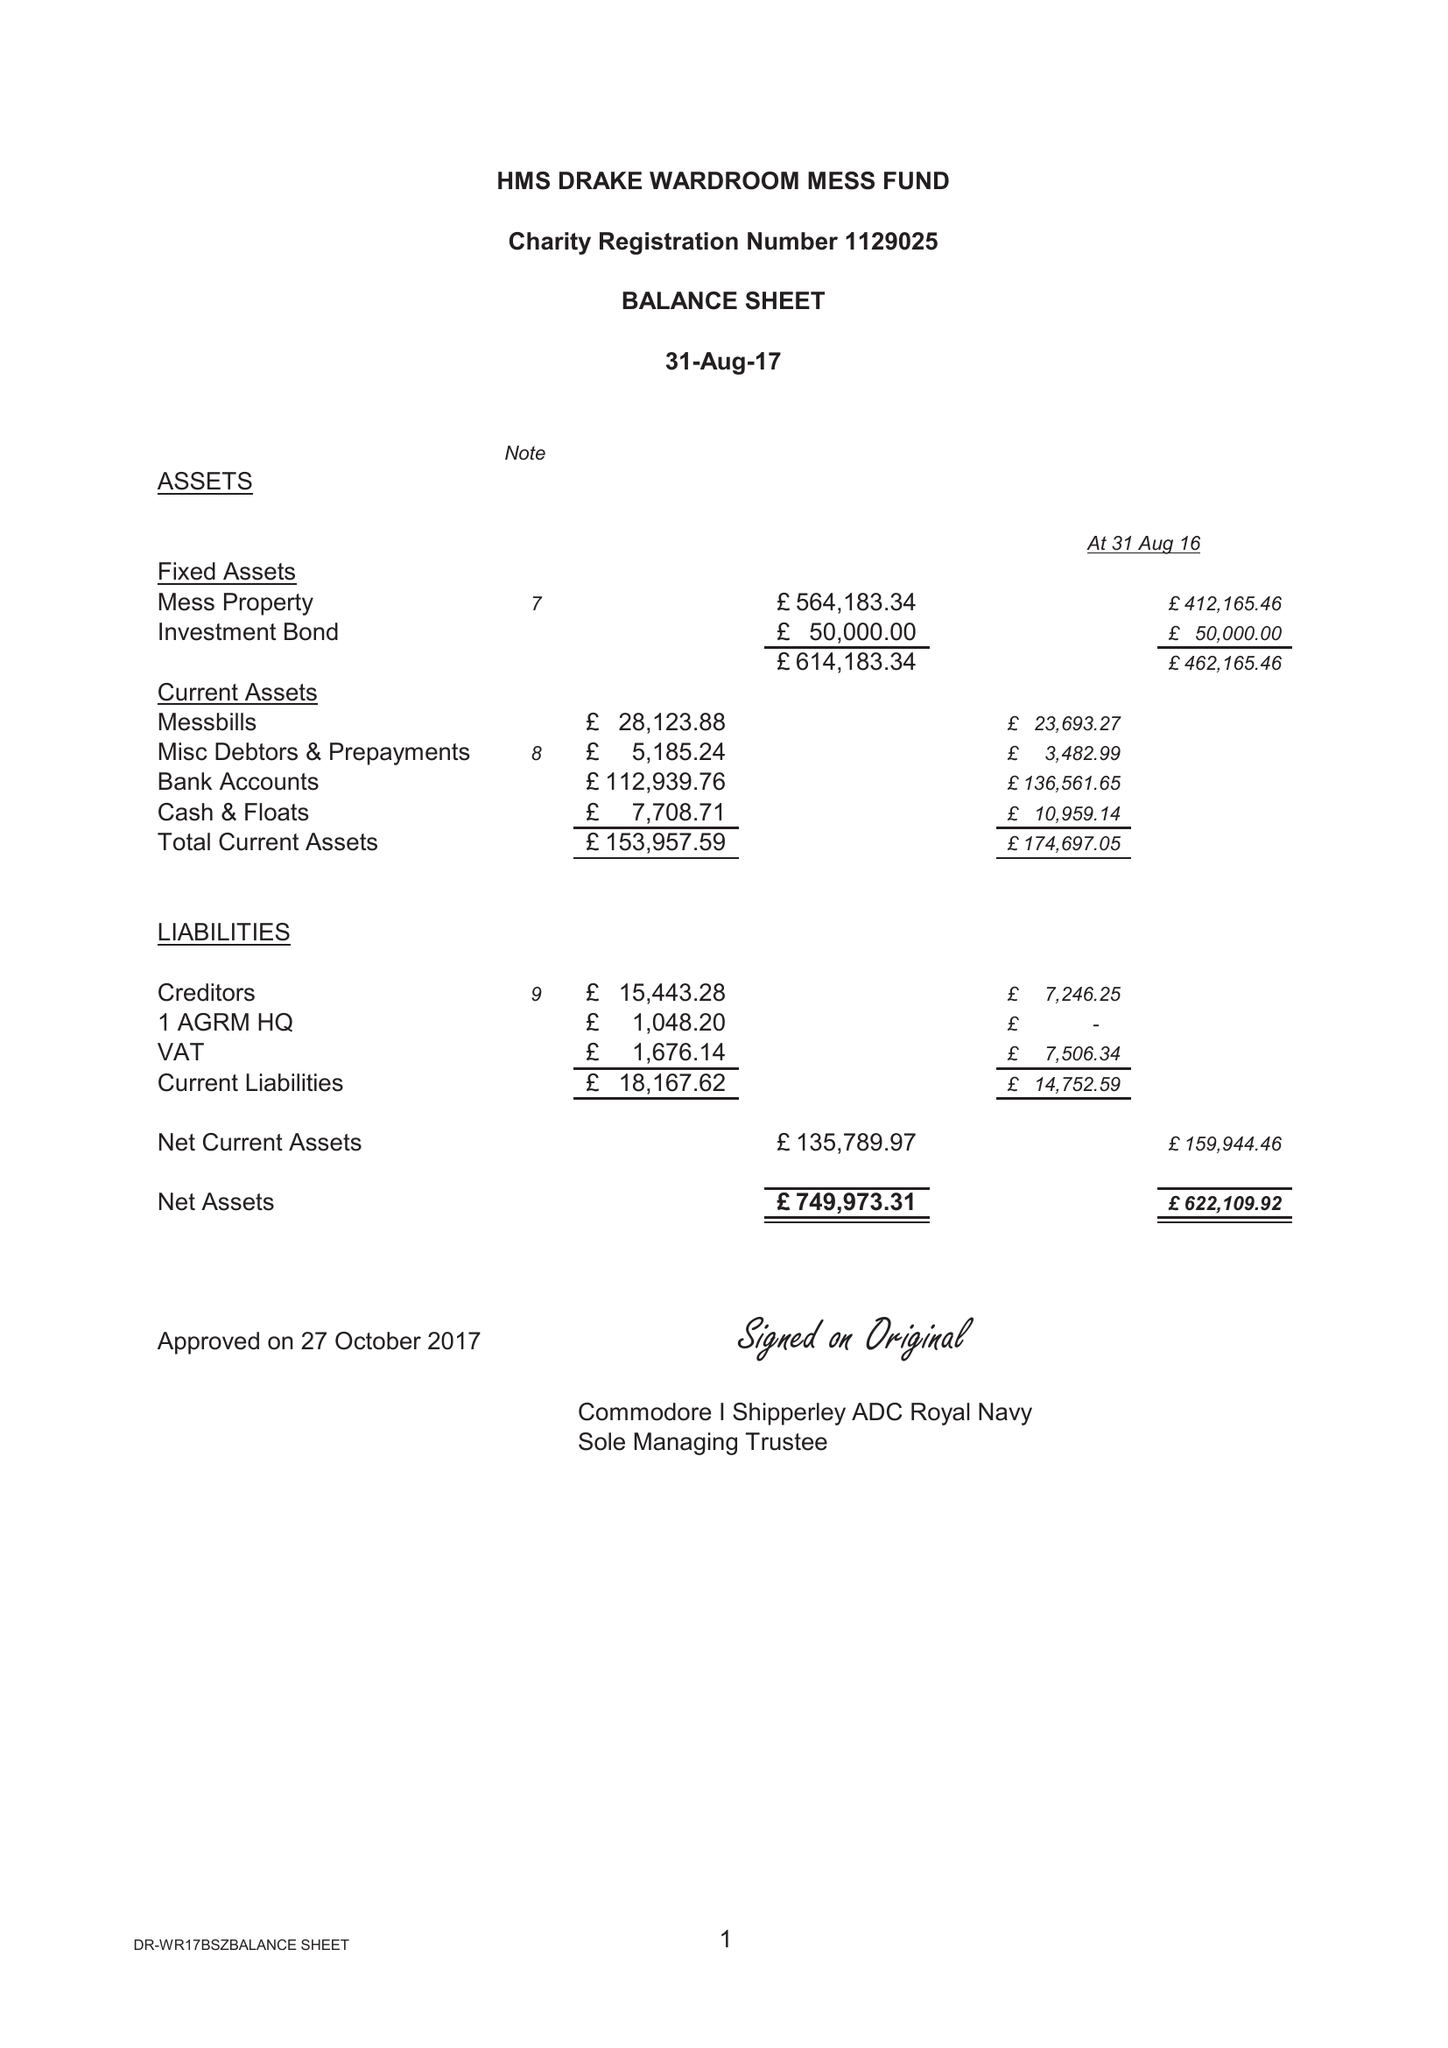What is the value for the address__street_line?
Answer the question using a single word or phrase. None 